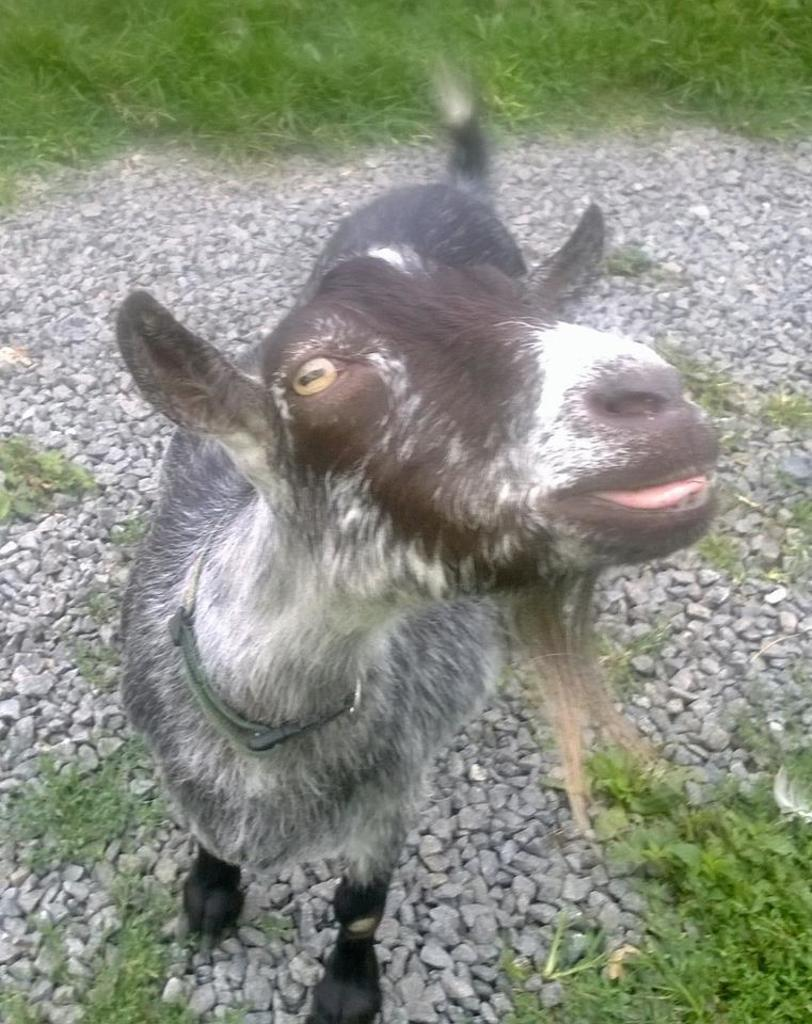What is the main subject in the center of the image? There is an animal in the center of the image. What type of vegetation is at the bottom of the image? There is grass at the bottom of the image. What other objects can be seen in the image? There are stones visible in the image. Where is the river flowing in the image? There is no river present in the image. What type of cake is being served in the image? There is no cake present in the image. 